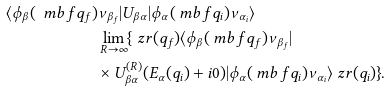<formula> <loc_0><loc_0><loc_500><loc_500>\langle \phi _ { \beta } ( \ m b f { q } _ { f } ) & \nu _ { \beta _ { f } } | U _ { \beta \alpha } | \phi _ { \alpha } ( \ m b f { q } _ { i } ) \nu _ { \alpha _ { i } } \rangle \\ & \lim _ { R \to \infty } \{ \ z r ( q _ { f } ) \langle \phi _ { \beta } ( \ m b f { q } _ { f } ) \nu _ { \beta _ { f } } | \\ & \times U ^ { ( R ) } _ { \beta \alpha } ( E _ { \alpha } ( q _ { i } ) + i 0 ) | \phi _ { \alpha } ( \ m b f { q } _ { i } ) \nu _ { \alpha _ { i } } \rangle \ z r ( q _ { i } ) \} .</formula> 